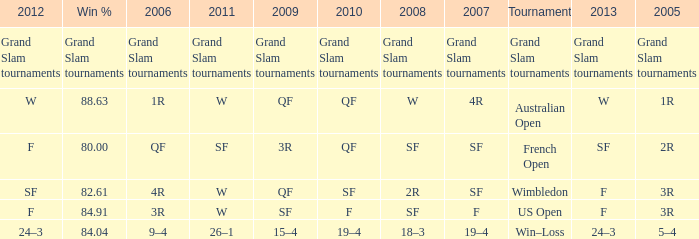When in 2008 that has a 2007 of f? SF. 